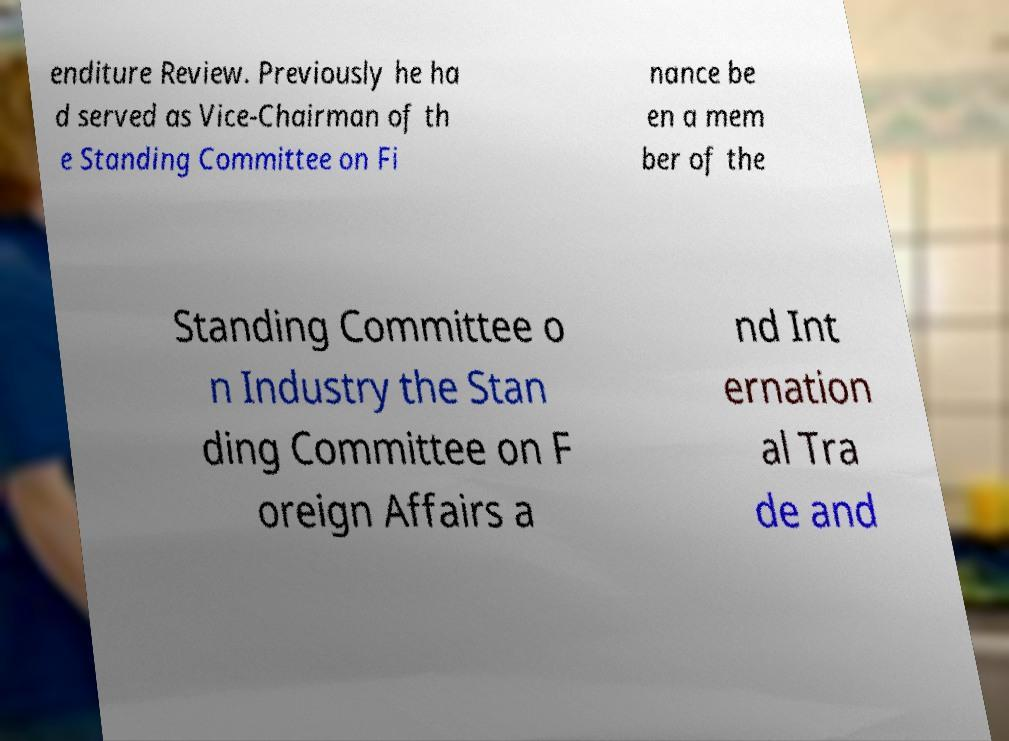Could you assist in decoding the text presented in this image and type it out clearly? enditure Review. Previously he ha d served as Vice-Chairman of th e Standing Committee on Fi nance be en a mem ber of the Standing Committee o n Industry the Stan ding Committee on F oreign Affairs a nd Int ernation al Tra de and 